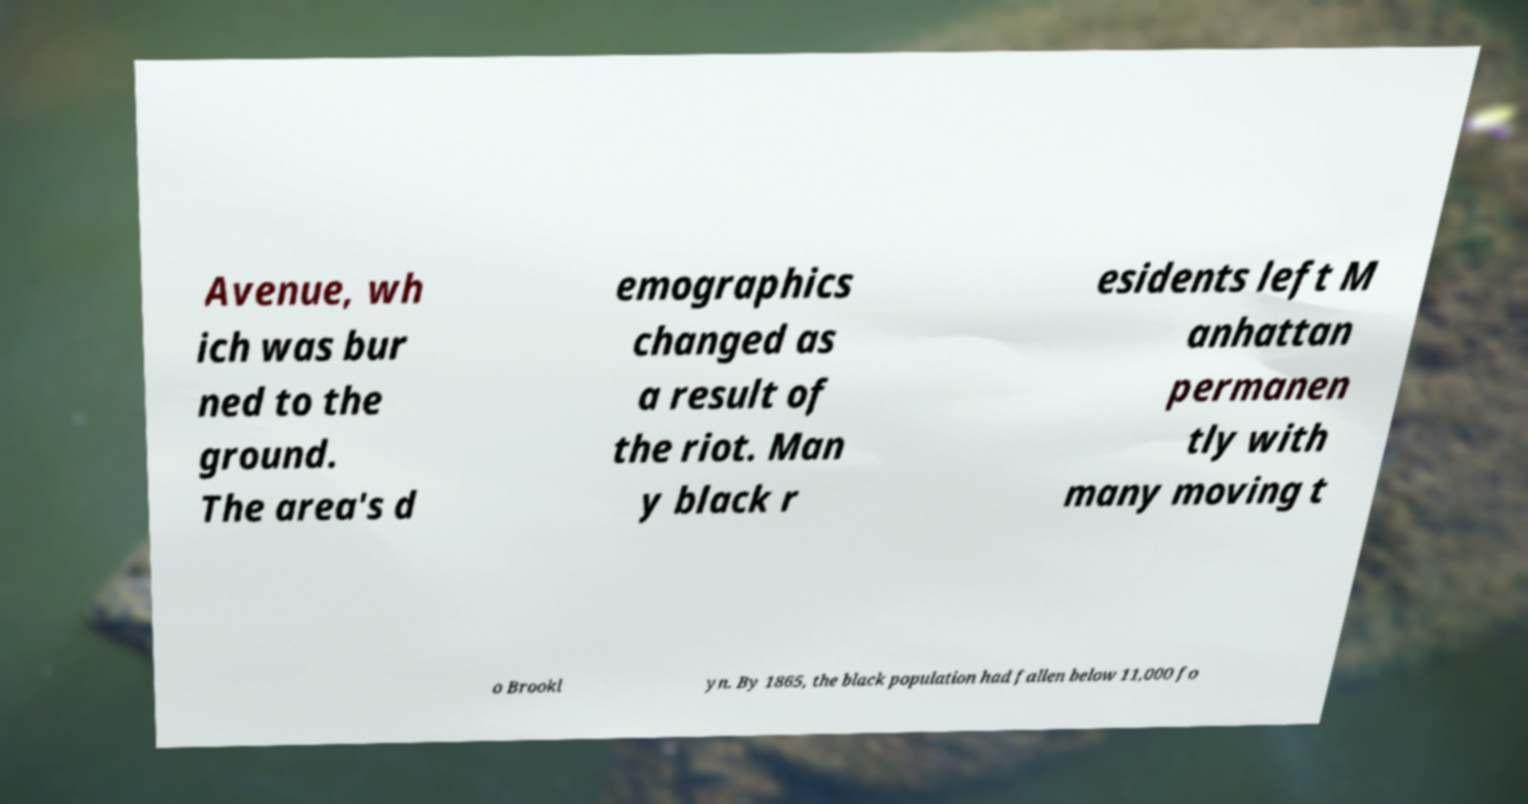Can you accurately transcribe the text from the provided image for me? Avenue, wh ich was bur ned to the ground. The area's d emographics changed as a result of the riot. Man y black r esidents left M anhattan permanen tly with many moving t o Brookl yn. By 1865, the black population had fallen below 11,000 fo 